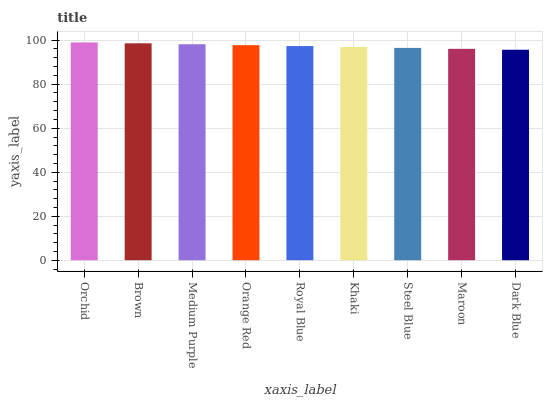Is Dark Blue the minimum?
Answer yes or no. Yes. Is Orchid the maximum?
Answer yes or no. Yes. Is Brown the minimum?
Answer yes or no. No. Is Brown the maximum?
Answer yes or no. No. Is Orchid greater than Brown?
Answer yes or no. Yes. Is Brown less than Orchid?
Answer yes or no. Yes. Is Brown greater than Orchid?
Answer yes or no. No. Is Orchid less than Brown?
Answer yes or no. No. Is Royal Blue the high median?
Answer yes or no. Yes. Is Royal Blue the low median?
Answer yes or no. Yes. Is Maroon the high median?
Answer yes or no. No. Is Brown the low median?
Answer yes or no. No. 